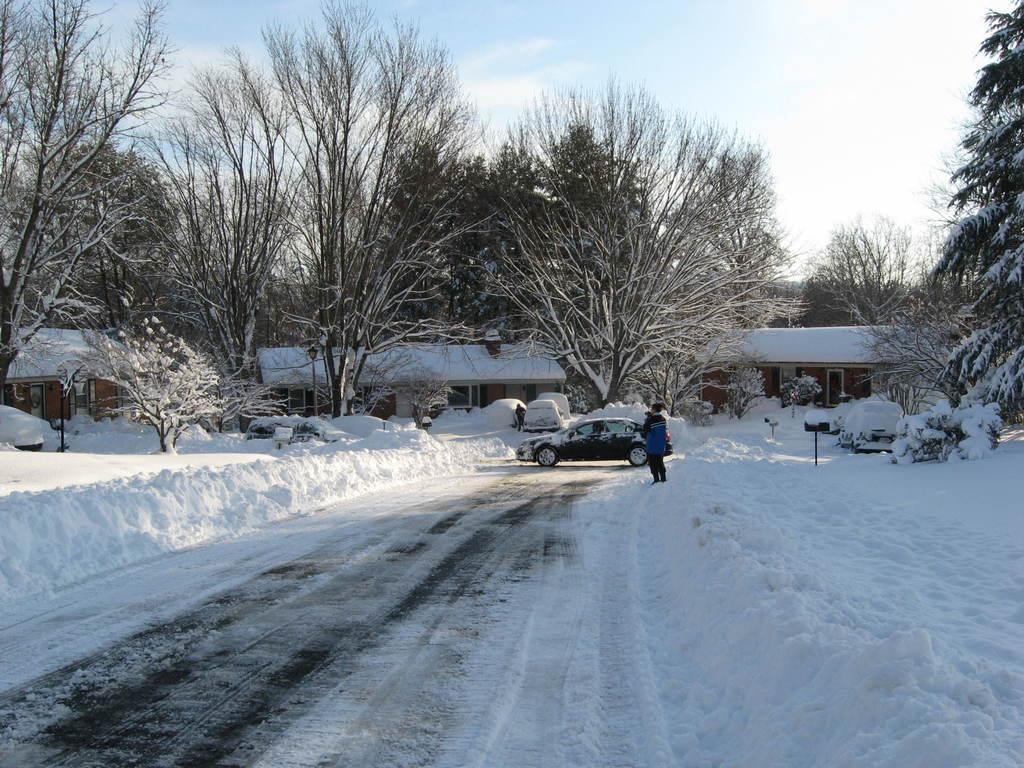What is the weather condition in the image? There is snow in the image, indicating a cold and wintry weather condition. What types of vehicles are present in the image? There are vehicles in the image, but the specific types are not mentioned. Can you describe the person in the image? There is a person standing in the image, but their appearance or clothing is not described. What can be seen in the background of the image? There are trees and clouds in the sky in the background of the image. What type of card is being used to lead the snow in the image? There is no card or any indication of leading the snow in the image. 